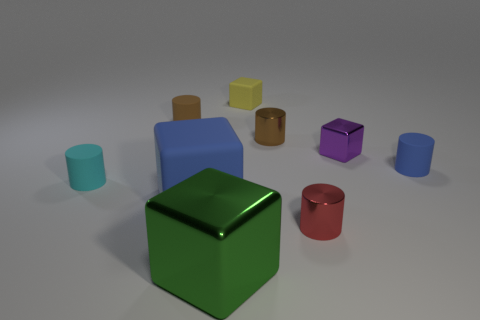Are there any small blue objects?
Your answer should be very brief. Yes. Is the color of the big shiny thing the same as the tiny matte cylinder that is to the right of the small red metallic cylinder?
Keep it short and to the point. No. What color is the large rubber block?
Your answer should be very brief. Blue. Is there anything else that has the same shape as the red object?
Keep it short and to the point. Yes. There is a big shiny object that is the same shape as the large rubber thing; what color is it?
Keep it short and to the point. Green. Is the shape of the brown metal thing the same as the purple shiny object?
Ensure brevity in your answer.  No. What number of balls are red metallic things or tiny purple objects?
Your answer should be compact. 0. There is another cube that is the same material as the green cube; what color is it?
Your answer should be compact. Purple. Is the size of the rubber block that is behind the cyan thing the same as the small brown matte cylinder?
Make the answer very short. Yes. Is the material of the big green block the same as the small block that is to the right of the tiny red thing?
Provide a succinct answer. Yes. 